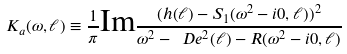<formula> <loc_0><loc_0><loc_500><loc_500>K _ { a } ( \omega , \ell ) \equiv \frac { 1 } { \pi } \text {Im} \frac { ( h ( \ell ) - S _ { 1 } ( \omega ^ { 2 } - i 0 , \ell ) ) ^ { 2 } } { \omega ^ { 2 } - \ D e ^ { 2 } ( \ell ) - R ( \omega ^ { 2 } - i 0 , \ell ) }</formula> 